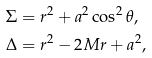<formula> <loc_0><loc_0><loc_500><loc_500>\Sigma & = r ^ { 2 } + a ^ { 2 } \cos ^ { 2 } \theta , \\ \Delta & = r ^ { 2 } - 2 M r + a ^ { 2 } ,</formula> 